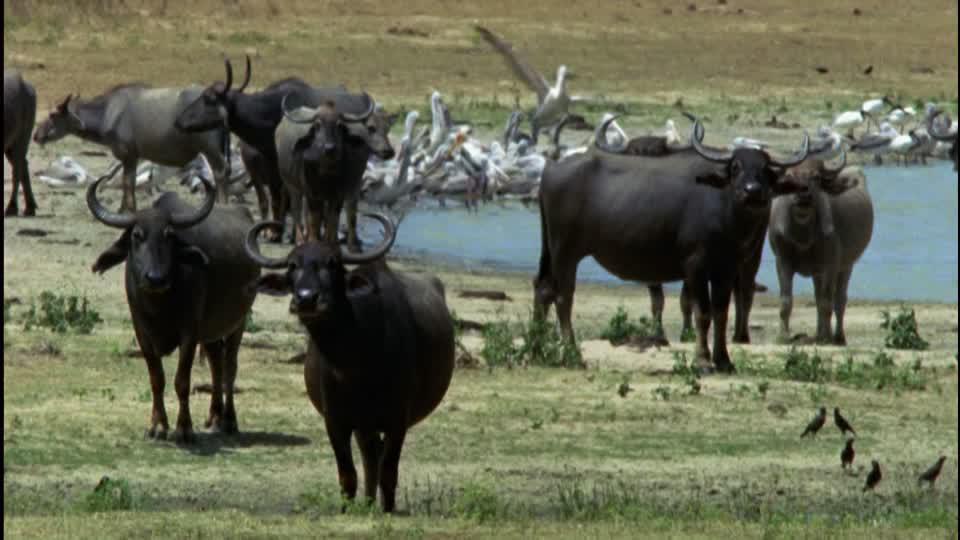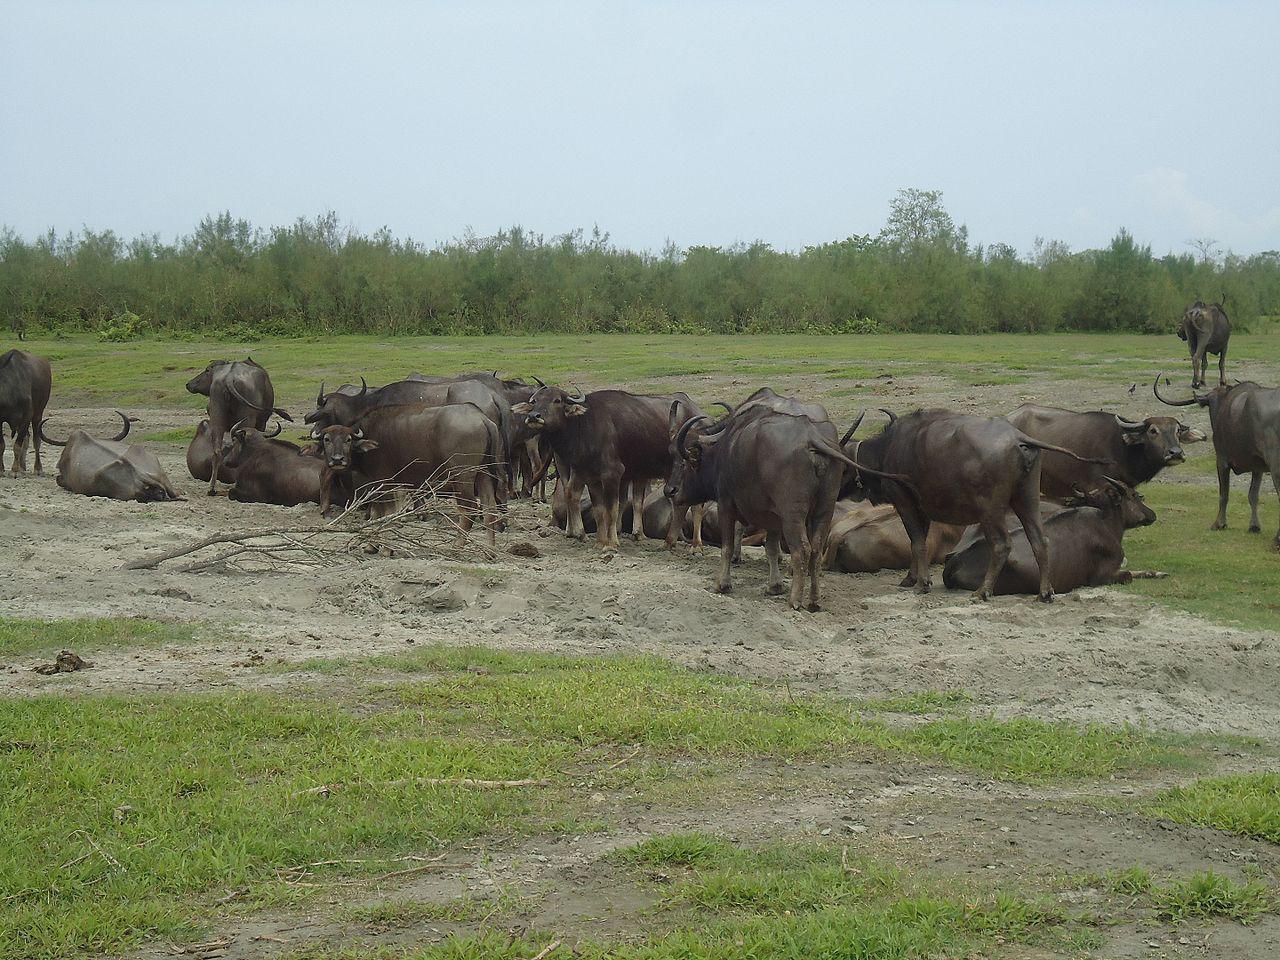The first image is the image on the left, the second image is the image on the right. Analyze the images presented: Is the assertion "There is an area of water seen behind some of the animals in the image on the left." valid? Answer yes or no. Yes. The first image is the image on the left, the second image is the image on the right. For the images shown, is this caption "An image shows water buffalo standing with a pool of water behind them, but not in front of them." true? Answer yes or no. Yes. 